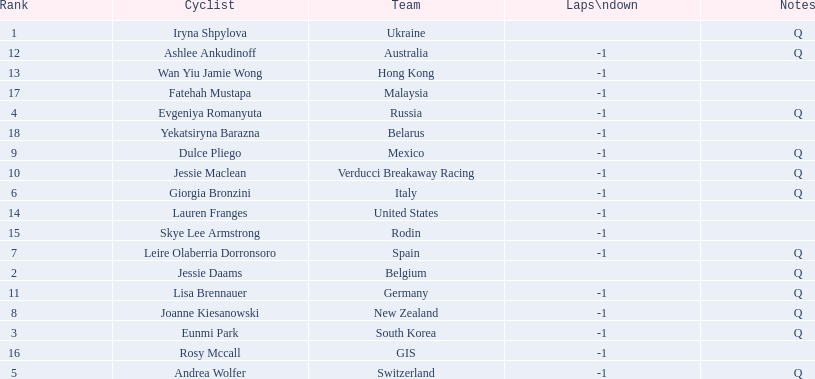Who are all of the cyclists in this race? Iryna Shpylova, Jessie Daams, Eunmi Park, Evgeniya Romanyuta, Andrea Wolfer, Giorgia Bronzini, Leire Olaberria Dorronsoro, Joanne Kiesanowski, Dulce Pliego, Jessie Maclean, Lisa Brennauer, Ashlee Ankudinoff, Wan Yiu Jamie Wong, Lauren Franges, Skye Lee Armstrong, Rosy Mccall, Fatehah Mustapa, Yekatsiryna Barazna. Of these, which one has the lowest numbered rank? Iryna Shpylova. 